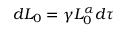Convert formula to latex. <formula><loc_0><loc_0><loc_500><loc_500>\begin{array} { r } { d L _ { 0 } = \gamma L _ { 0 } ^ { \alpha } d \tau \ } \end{array}</formula> 